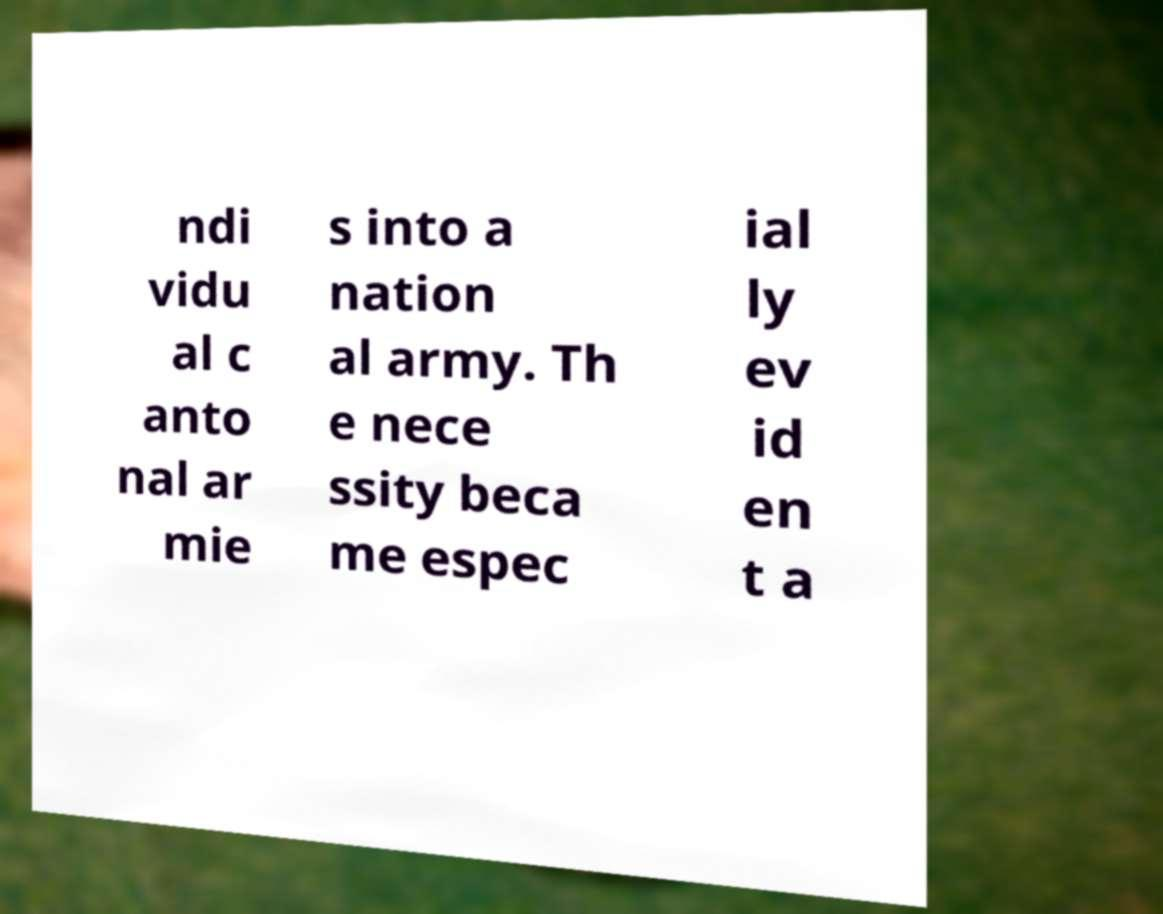Can you read and provide the text displayed in the image?This photo seems to have some interesting text. Can you extract and type it out for me? ndi vidu al c anto nal ar mie s into a nation al army. Th e nece ssity beca me espec ial ly ev id en t a 